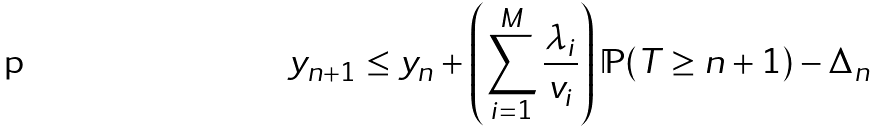Convert formula to latex. <formula><loc_0><loc_0><loc_500><loc_500>y _ { n + 1 } \leq y _ { n } + \left ( \sum _ { i = 1 } ^ { M } \frac { \lambda _ { i } } { v _ { i } } \right ) \mathbb { P } ( T \geq n + 1 ) - \Delta _ { n }</formula> 